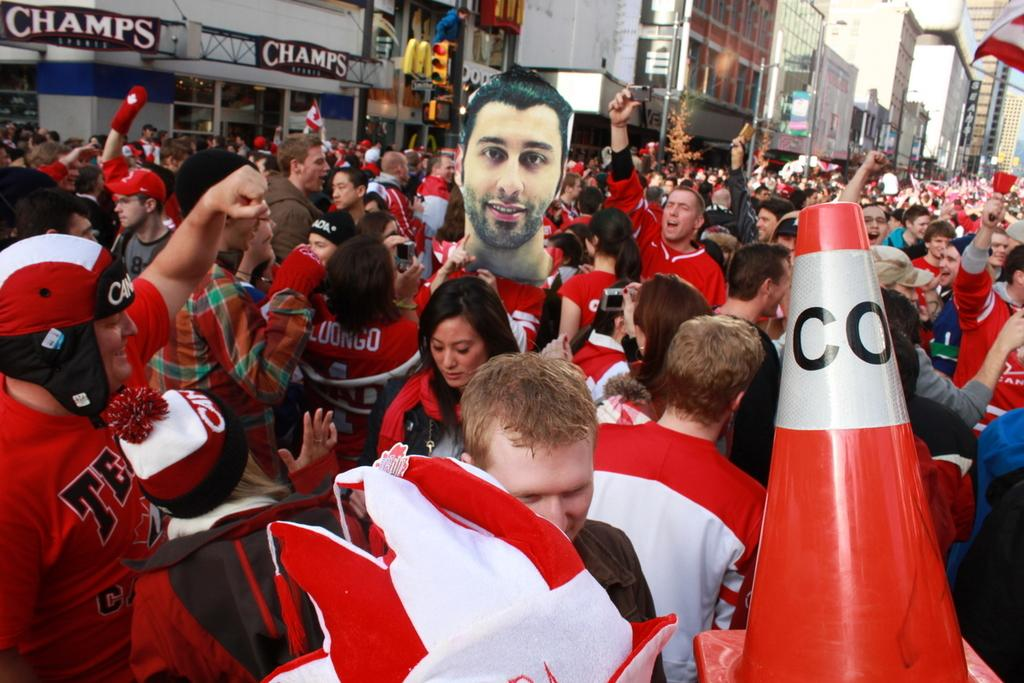What can be seen in the image in terms of people? There are groups of people in the image. What type of structures are visible in the image? There are buildings in the image. What traffic control device is present in the image? There is a traffic light in the image. What symbol or emblem can be seen in the image? There is a flag in the image. How does the gate provide pleasure to the people in the image? There is no gate present in the image, so it cannot provide pleasure to the people. 